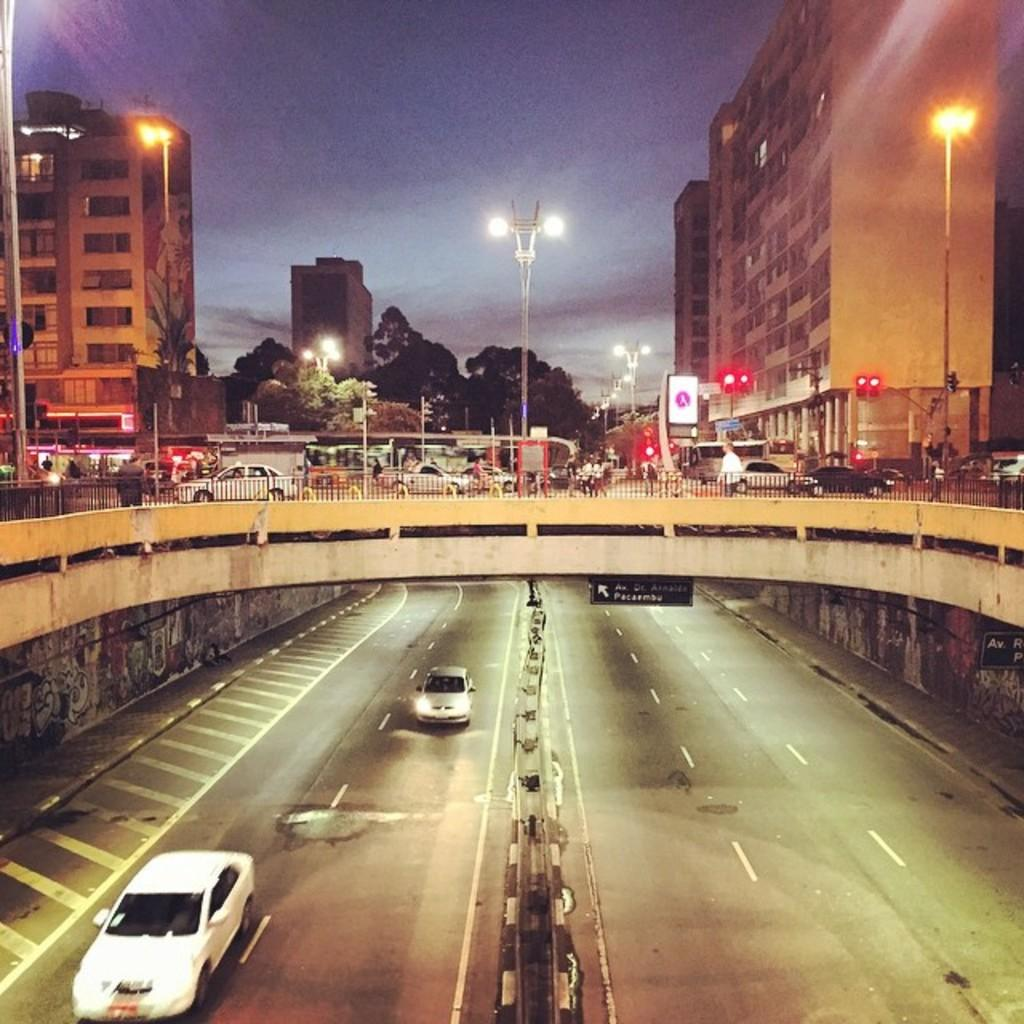What type of structure can be seen in the image? There is a bridge in the image. What is happening on the roads in the image? Vehicles are present on the roads in the image. What can be seen in the background of the image? There are trees, buildings, street lights, and a fence in the background of the image. What type of lighting is present in the background of the image? Traffic lights are visible in the background of the image. What is visible in the sky in the image? The sky is visible in the image. What type of stew is being served at the restaurant in the image? There is no restaurant or stew present in the image. Who is the representative of the city in the image? There is no representative identified in the image. 